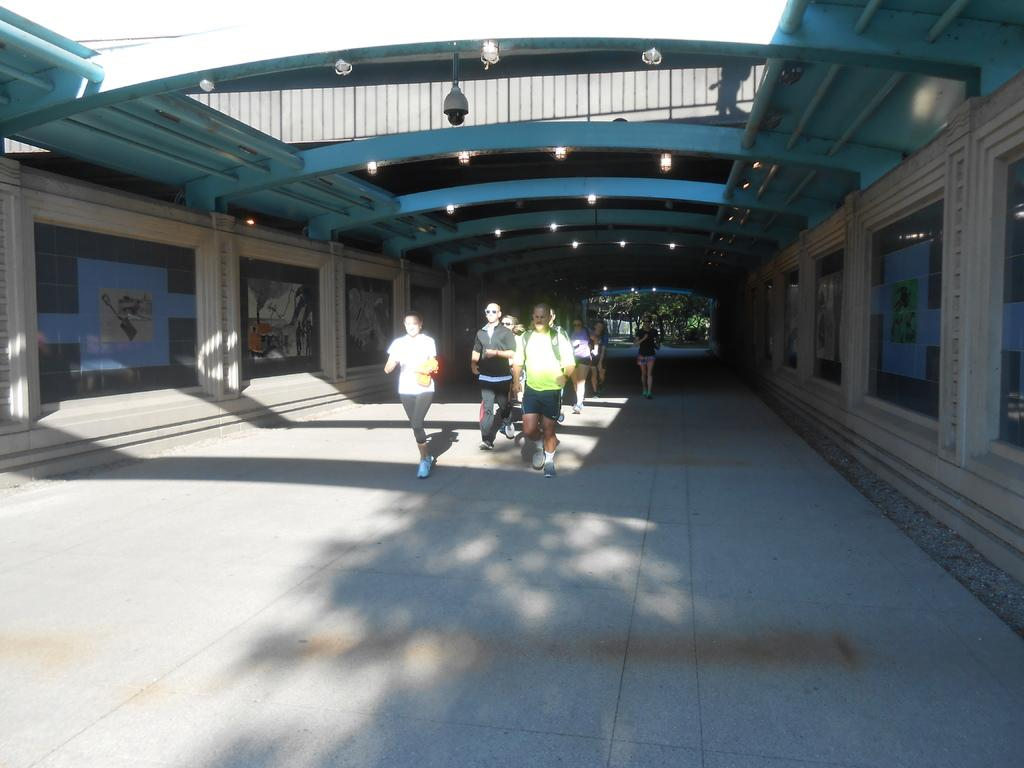How many people are in the image? There is a group of people in the image. Where are the people located in the image? The people are standing under a shed. What can be seen in the image besides the people? There are group of lights in the image. What is visible in the background of the image? There are photo frames and a CCTV camera in the background of the image. How many giants are present in the image? There are no giants present in the image; it features a group of people. What type of shoe can be seen on the side of the image? There is no shoe visible on the side of the image. 